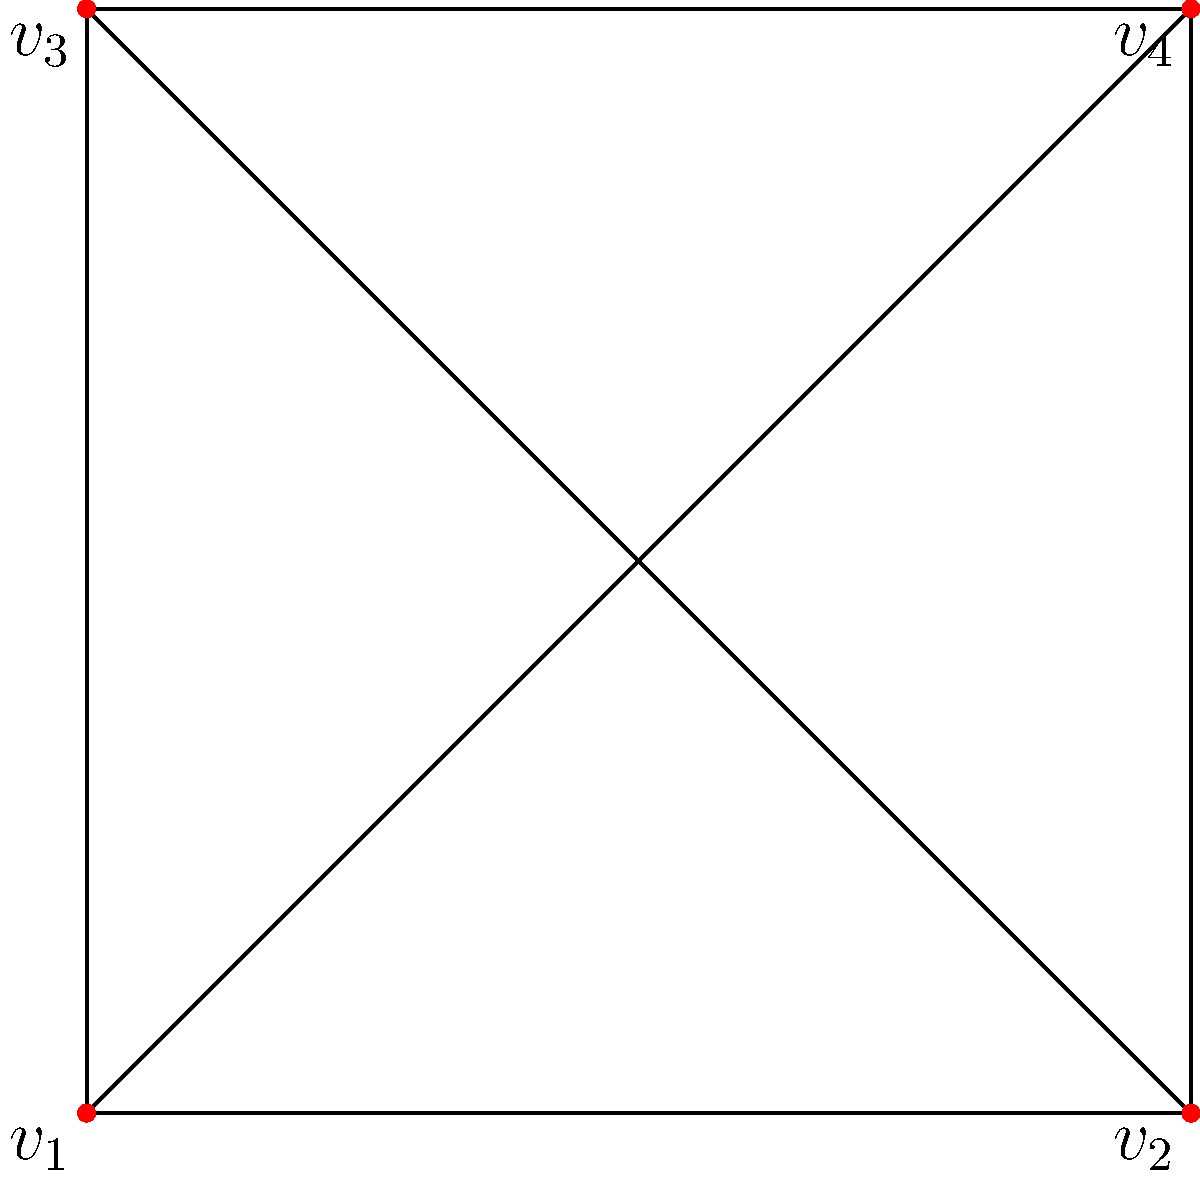Consider the graph $G$ shown above. The automorphism group $\text{Aut}(G)$ acts on the set of vertices $V = \{v_1, v_2, v_3, v_4\}$. Using the orbit-stabilizer theorem, determine the size of the orbit of vertex $v_1$ under this action. To solve this problem, we'll follow these steps:

1) First, we need to identify $\text{Aut}(G)$. The automorphisms of this graph are:
   - Identity
   - Rotation by 180 degrees (swapping $v_1$ with $v_4$ and $v_2$ with $v_3$)
   - Reflection about the diagonal $v_1$-$v_4$
   - Reflection about the diagonal $v_2$-$v_3$

   So, $|\text{Aut}(G)| = 4$

2) Now, let's consider the stabilizer of $v_1$, denoted as $\text{Stab}(v_1)$. This is the set of automorphisms that fix $v_1$. There are two such automorphisms:
   - Identity
   - Reflection about the diagonal $v_1$-$v_4$

   So, $|\text{Stab}(v_1)| = 2$

3) The orbit-stabilizer theorem states that:

   $$|\text{Orb}(v_1)| \cdot |\text{Stab}(v_1)| = |\text{Aut}(G)|$$

4) Substituting the values we know:

   $$|\text{Orb}(v_1)| \cdot 2 = 4$$

5) Solving for $|\text{Orb}(v_1)|$:

   $$|\text{Orb}(v_1)| = 4 / 2 = 2$$

Therefore, the size of the orbit of $v_1$ under the action of $\text{Aut}(G)$ is 2.
Answer: 2 